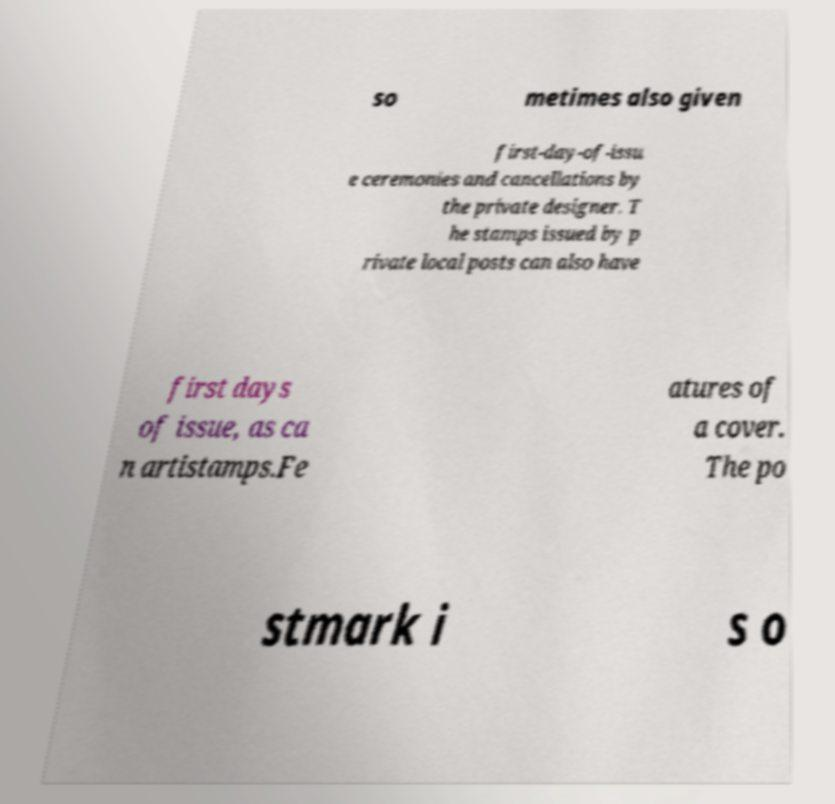Can you read and provide the text displayed in the image?This photo seems to have some interesting text. Can you extract and type it out for me? so metimes also given first-day-of-issu e ceremonies and cancellations by the private designer. T he stamps issued by p rivate local posts can also have first days of issue, as ca n artistamps.Fe atures of a cover. The po stmark i s o 